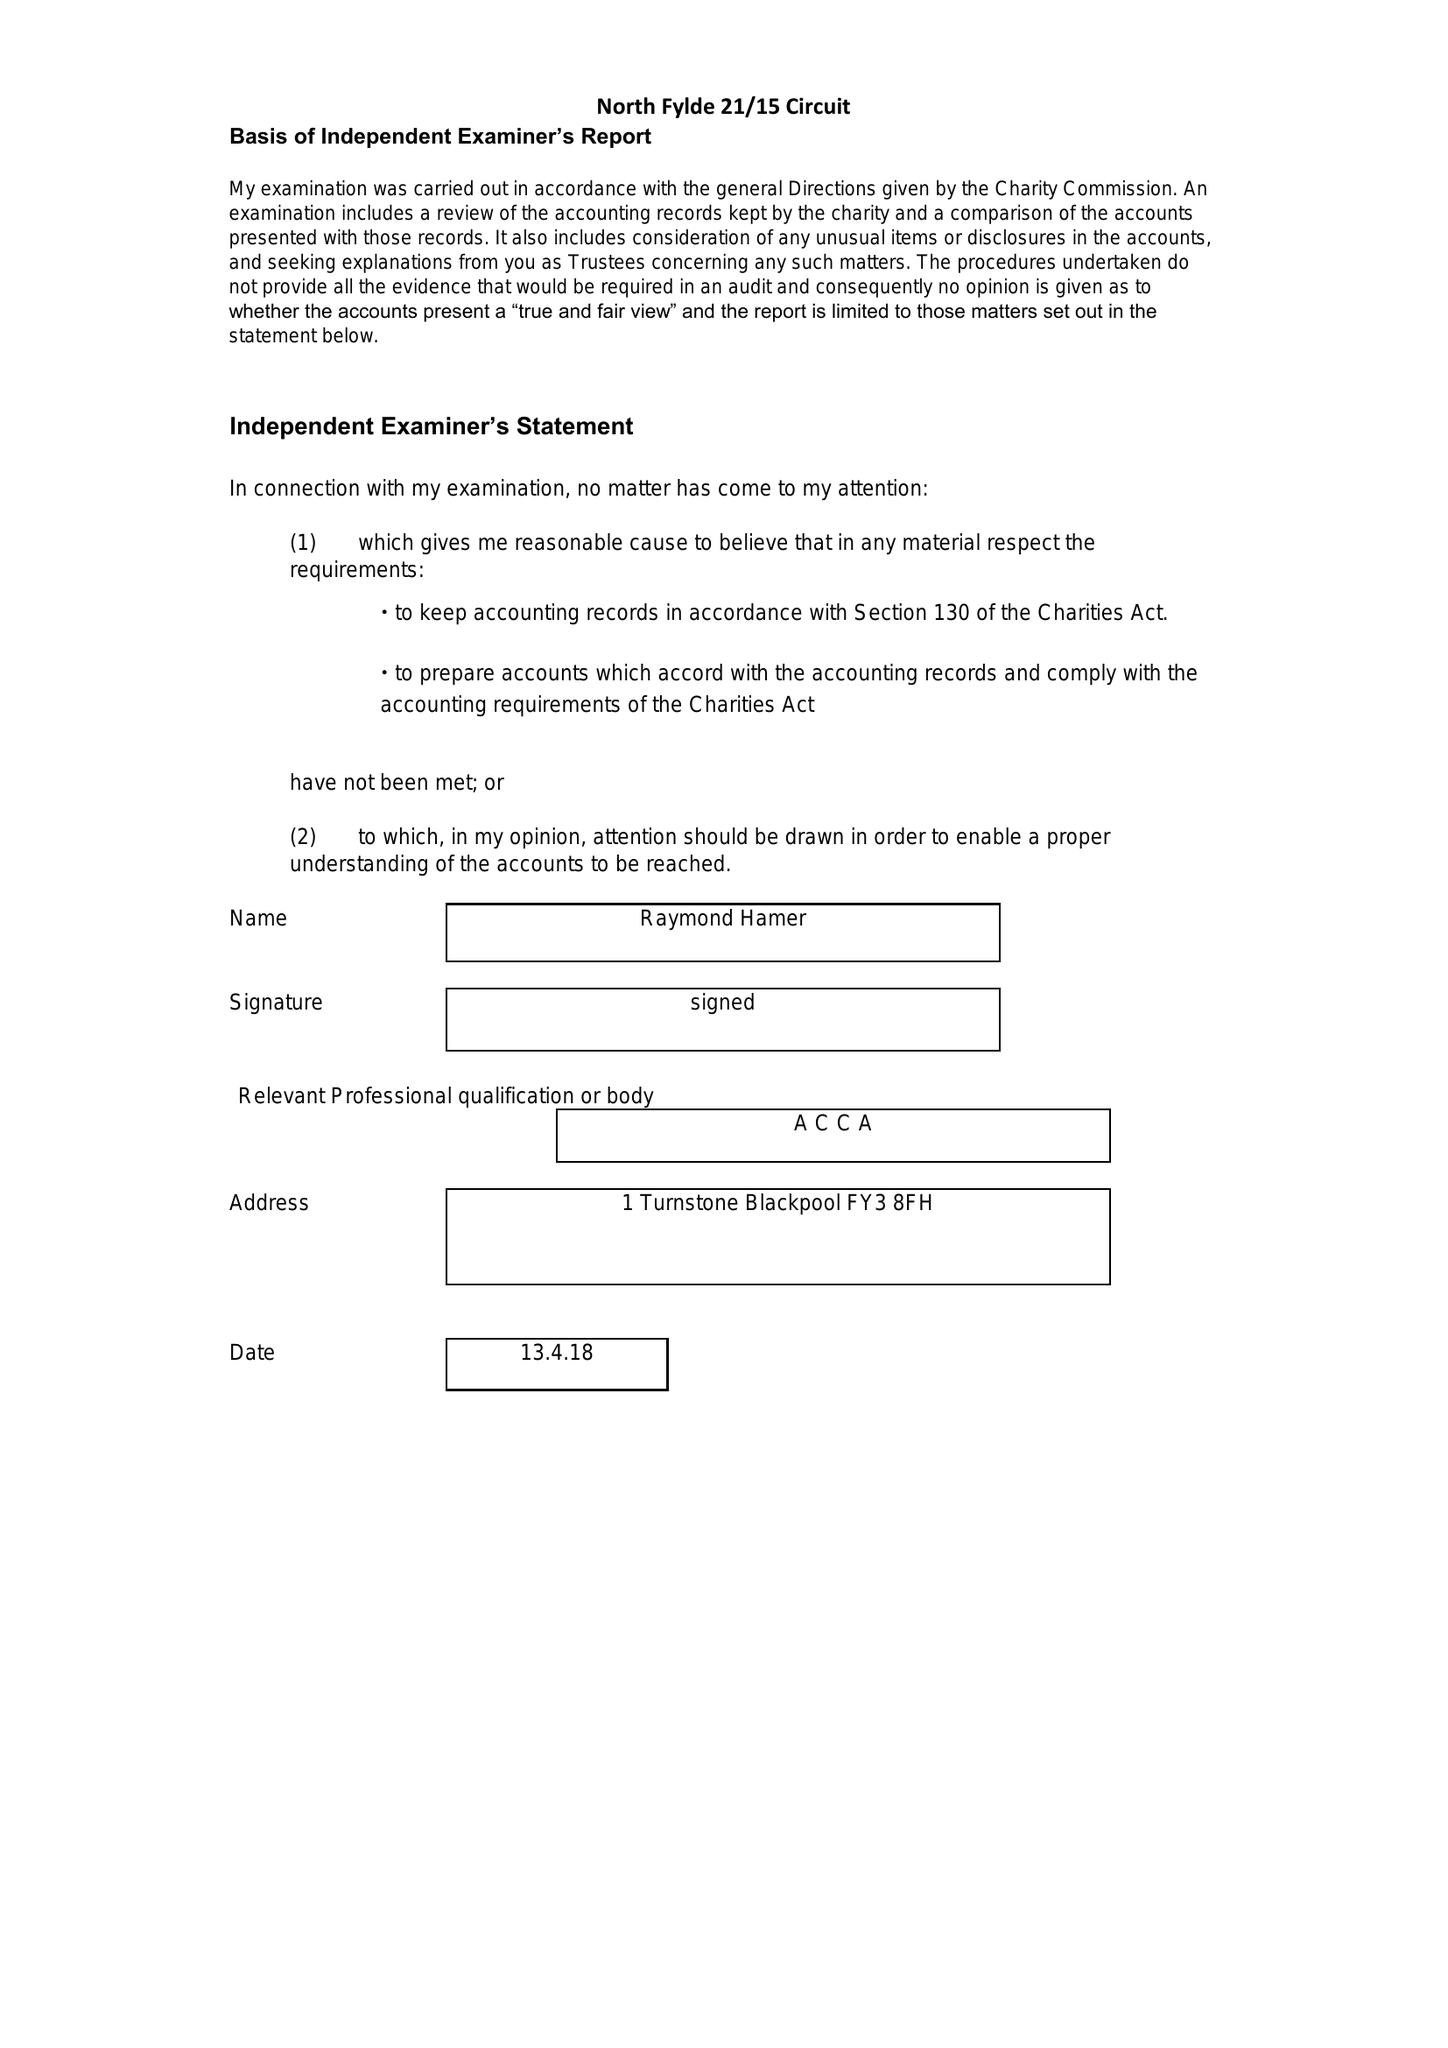What is the value for the address__street_line?
Answer the question using a single word or phrase. 2 COTTAM PLACE 